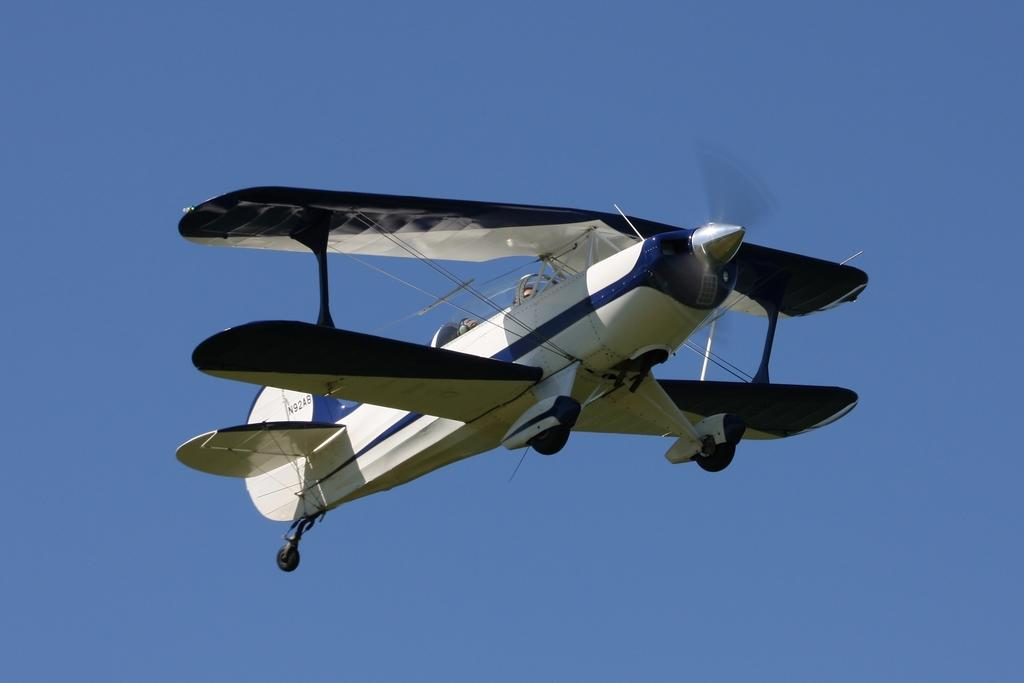What is the main subject of the image? There is a flying object in the image. Where is the flying object located? The flying object is in the sky. What can be seen in the background of the image? The background of the image is the sky. What type of butter is being used to grease the queen's hands in the image? There is no butter or queen present in the image; it features a flying object in the sky. How is the aunt related to the flying object in the image? There is no aunt mentioned or depicted in the image; it only shows a flying object in the sky. 